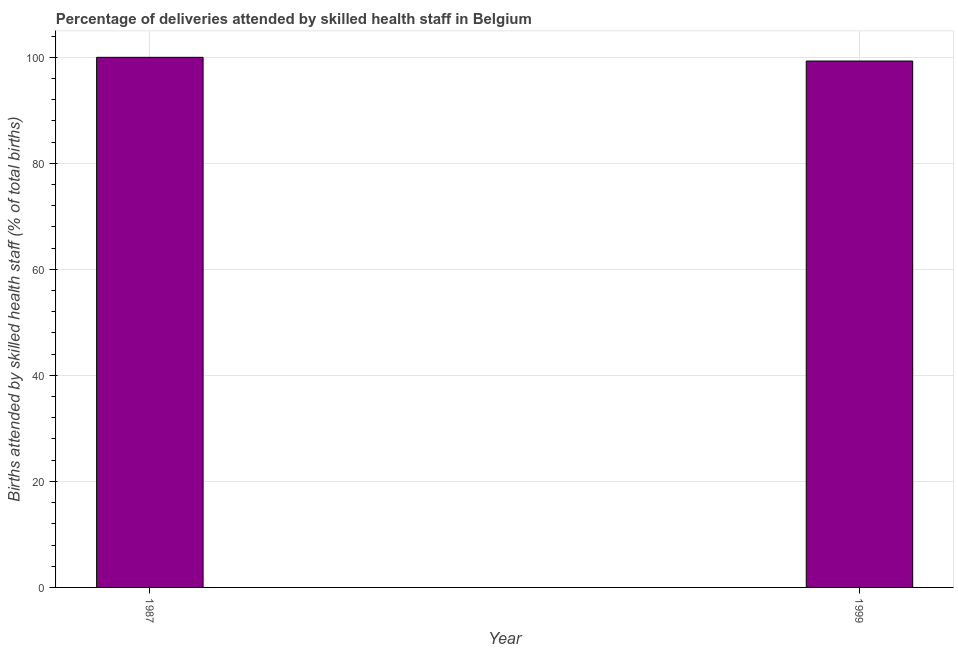Does the graph contain any zero values?
Your answer should be compact. No. Does the graph contain grids?
Make the answer very short. Yes. What is the title of the graph?
Ensure brevity in your answer.  Percentage of deliveries attended by skilled health staff in Belgium. What is the label or title of the Y-axis?
Your answer should be very brief. Births attended by skilled health staff (% of total births). What is the number of births attended by skilled health staff in 1999?
Make the answer very short. 99.3. Across all years, what is the minimum number of births attended by skilled health staff?
Provide a succinct answer. 99.3. What is the sum of the number of births attended by skilled health staff?
Provide a succinct answer. 199.3. What is the difference between the number of births attended by skilled health staff in 1987 and 1999?
Ensure brevity in your answer.  0.7. What is the average number of births attended by skilled health staff per year?
Provide a succinct answer. 99.65. What is the median number of births attended by skilled health staff?
Provide a succinct answer. 99.65. Is the number of births attended by skilled health staff in 1987 less than that in 1999?
Ensure brevity in your answer.  No. In how many years, is the number of births attended by skilled health staff greater than the average number of births attended by skilled health staff taken over all years?
Offer a terse response. 1. How many bars are there?
Provide a succinct answer. 2. How many years are there in the graph?
Offer a very short reply. 2. What is the difference between two consecutive major ticks on the Y-axis?
Ensure brevity in your answer.  20. Are the values on the major ticks of Y-axis written in scientific E-notation?
Your response must be concise. No. What is the Births attended by skilled health staff (% of total births) in 1999?
Give a very brief answer. 99.3. What is the ratio of the Births attended by skilled health staff (% of total births) in 1987 to that in 1999?
Provide a succinct answer. 1.01. 